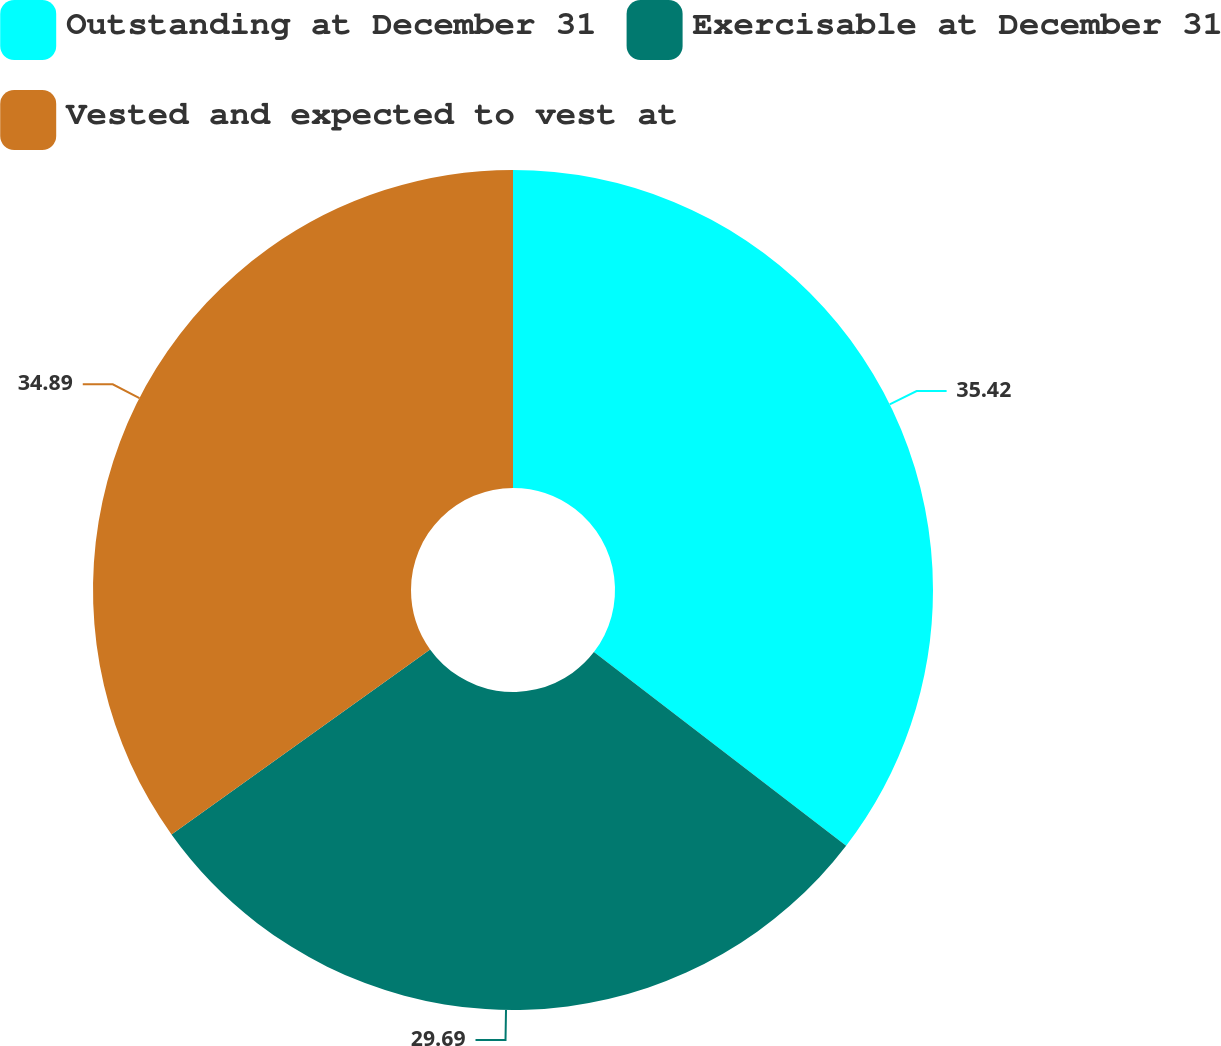<chart> <loc_0><loc_0><loc_500><loc_500><pie_chart><fcel>Outstanding at December 31<fcel>Exercisable at December 31<fcel>Vested and expected to vest at<nl><fcel>35.42%<fcel>29.69%<fcel>34.89%<nl></chart> 